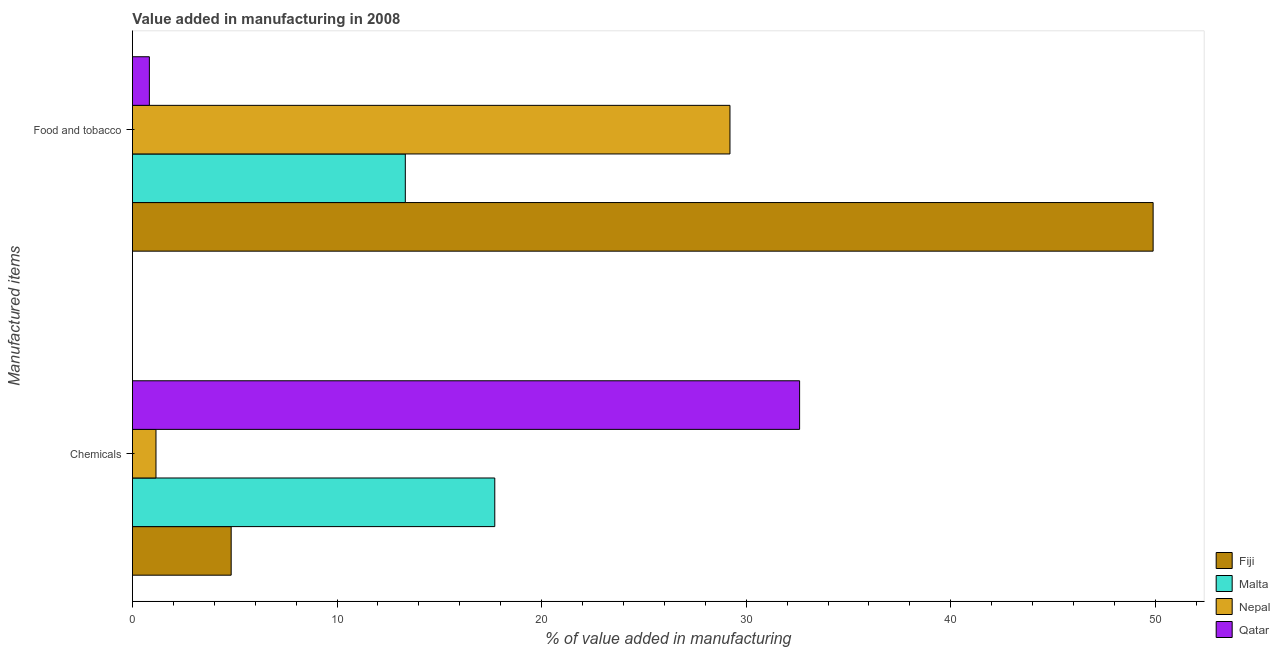How many groups of bars are there?
Provide a succinct answer. 2. How many bars are there on the 1st tick from the top?
Make the answer very short. 4. What is the label of the 1st group of bars from the top?
Ensure brevity in your answer.  Food and tobacco. What is the value added by  manufacturing chemicals in Fiji?
Keep it short and to the point. 4.83. Across all countries, what is the maximum value added by manufacturing food and tobacco?
Give a very brief answer. 49.89. Across all countries, what is the minimum value added by  manufacturing chemicals?
Give a very brief answer. 1.15. In which country was the value added by  manufacturing chemicals maximum?
Provide a succinct answer. Qatar. In which country was the value added by  manufacturing chemicals minimum?
Offer a terse response. Nepal. What is the total value added by manufacturing food and tobacco in the graph?
Provide a short and direct response. 93.26. What is the difference between the value added by  manufacturing chemicals in Qatar and that in Nepal?
Ensure brevity in your answer.  31.46. What is the difference between the value added by manufacturing food and tobacco in Fiji and the value added by  manufacturing chemicals in Malta?
Your response must be concise. 32.18. What is the average value added by  manufacturing chemicals per country?
Your answer should be very brief. 14.07. What is the difference between the value added by manufacturing food and tobacco and value added by  manufacturing chemicals in Nepal?
Provide a succinct answer. 28.06. In how many countries, is the value added by manufacturing food and tobacco greater than 32 %?
Your answer should be very brief. 1. What is the ratio of the value added by manufacturing food and tobacco in Fiji to that in Malta?
Keep it short and to the point. 3.74. What does the 3rd bar from the top in Chemicals represents?
Your response must be concise. Malta. What does the 2nd bar from the bottom in Food and tobacco represents?
Your answer should be very brief. Malta. How many countries are there in the graph?
Keep it short and to the point. 4. Does the graph contain any zero values?
Your response must be concise. No. How many legend labels are there?
Offer a very short reply. 4. What is the title of the graph?
Offer a terse response. Value added in manufacturing in 2008. Does "Turks and Caicos Islands" appear as one of the legend labels in the graph?
Give a very brief answer. No. What is the label or title of the X-axis?
Offer a terse response. % of value added in manufacturing. What is the label or title of the Y-axis?
Your answer should be very brief. Manufactured items. What is the % of value added in manufacturing of Fiji in Chemicals?
Ensure brevity in your answer.  4.83. What is the % of value added in manufacturing in Malta in Chemicals?
Ensure brevity in your answer.  17.71. What is the % of value added in manufacturing of Nepal in Chemicals?
Offer a very short reply. 1.15. What is the % of value added in manufacturing of Qatar in Chemicals?
Offer a very short reply. 32.61. What is the % of value added in manufacturing of Fiji in Food and tobacco?
Ensure brevity in your answer.  49.89. What is the % of value added in manufacturing of Malta in Food and tobacco?
Your answer should be compact. 13.34. What is the % of value added in manufacturing in Nepal in Food and tobacco?
Keep it short and to the point. 29.21. What is the % of value added in manufacturing of Qatar in Food and tobacco?
Provide a succinct answer. 0.83. Across all Manufactured items, what is the maximum % of value added in manufacturing of Fiji?
Keep it short and to the point. 49.89. Across all Manufactured items, what is the maximum % of value added in manufacturing of Malta?
Your response must be concise. 17.71. Across all Manufactured items, what is the maximum % of value added in manufacturing of Nepal?
Make the answer very short. 29.21. Across all Manufactured items, what is the maximum % of value added in manufacturing of Qatar?
Provide a succinct answer. 32.61. Across all Manufactured items, what is the minimum % of value added in manufacturing in Fiji?
Offer a very short reply. 4.83. Across all Manufactured items, what is the minimum % of value added in manufacturing of Malta?
Give a very brief answer. 13.34. Across all Manufactured items, what is the minimum % of value added in manufacturing of Nepal?
Make the answer very short. 1.15. Across all Manufactured items, what is the minimum % of value added in manufacturing in Qatar?
Give a very brief answer. 0.83. What is the total % of value added in manufacturing of Fiji in the graph?
Offer a very short reply. 54.72. What is the total % of value added in manufacturing of Malta in the graph?
Offer a very short reply. 31.05. What is the total % of value added in manufacturing of Nepal in the graph?
Your answer should be compact. 30.36. What is the total % of value added in manufacturing of Qatar in the graph?
Your response must be concise. 33.44. What is the difference between the % of value added in manufacturing in Fiji in Chemicals and that in Food and tobacco?
Provide a succinct answer. -45.06. What is the difference between the % of value added in manufacturing of Malta in Chemicals and that in Food and tobacco?
Your response must be concise. 4.37. What is the difference between the % of value added in manufacturing in Nepal in Chemicals and that in Food and tobacco?
Your answer should be very brief. -28.06. What is the difference between the % of value added in manufacturing in Qatar in Chemicals and that in Food and tobacco?
Your answer should be compact. 31.78. What is the difference between the % of value added in manufacturing of Fiji in Chemicals and the % of value added in manufacturing of Malta in Food and tobacco?
Give a very brief answer. -8.51. What is the difference between the % of value added in manufacturing in Fiji in Chemicals and the % of value added in manufacturing in Nepal in Food and tobacco?
Your answer should be compact. -24.38. What is the difference between the % of value added in manufacturing of Fiji in Chemicals and the % of value added in manufacturing of Qatar in Food and tobacco?
Keep it short and to the point. 4. What is the difference between the % of value added in manufacturing in Malta in Chemicals and the % of value added in manufacturing in Nepal in Food and tobacco?
Your answer should be compact. -11.5. What is the difference between the % of value added in manufacturing of Malta in Chemicals and the % of value added in manufacturing of Qatar in Food and tobacco?
Your answer should be very brief. 16.88. What is the difference between the % of value added in manufacturing in Nepal in Chemicals and the % of value added in manufacturing in Qatar in Food and tobacco?
Offer a very short reply. 0.32. What is the average % of value added in manufacturing in Fiji per Manufactured items?
Your response must be concise. 27.36. What is the average % of value added in manufacturing in Malta per Manufactured items?
Offer a very short reply. 15.52. What is the average % of value added in manufacturing of Nepal per Manufactured items?
Keep it short and to the point. 15.18. What is the average % of value added in manufacturing in Qatar per Manufactured items?
Offer a terse response. 16.72. What is the difference between the % of value added in manufacturing in Fiji and % of value added in manufacturing in Malta in Chemicals?
Provide a short and direct response. -12.88. What is the difference between the % of value added in manufacturing in Fiji and % of value added in manufacturing in Nepal in Chemicals?
Your answer should be compact. 3.68. What is the difference between the % of value added in manufacturing in Fiji and % of value added in manufacturing in Qatar in Chemicals?
Keep it short and to the point. -27.78. What is the difference between the % of value added in manufacturing of Malta and % of value added in manufacturing of Nepal in Chemicals?
Give a very brief answer. 16.56. What is the difference between the % of value added in manufacturing of Malta and % of value added in manufacturing of Qatar in Chemicals?
Your response must be concise. -14.9. What is the difference between the % of value added in manufacturing in Nepal and % of value added in manufacturing in Qatar in Chemicals?
Ensure brevity in your answer.  -31.46. What is the difference between the % of value added in manufacturing of Fiji and % of value added in manufacturing of Malta in Food and tobacco?
Offer a very short reply. 36.55. What is the difference between the % of value added in manufacturing in Fiji and % of value added in manufacturing in Nepal in Food and tobacco?
Give a very brief answer. 20.68. What is the difference between the % of value added in manufacturing of Fiji and % of value added in manufacturing of Qatar in Food and tobacco?
Offer a terse response. 49.06. What is the difference between the % of value added in manufacturing in Malta and % of value added in manufacturing in Nepal in Food and tobacco?
Offer a terse response. -15.87. What is the difference between the % of value added in manufacturing in Malta and % of value added in manufacturing in Qatar in Food and tobacco?
Offer a terse response. 12.51. What is the difference between the % of value added in manufacturing in Nepal and % of value added in manufacturing in Qatar in Food and tobacco?
Your answer should be compact. 28.38. What is the ratio of the % of value added in manufacturing in Fiji in Chemicals to that in Food and tobacco?
Offer a terse response. 0.1. What is the ratio of the % of value added in manufacturing in Malta in Chemicals to that in Food and tobacco?
Make the answer very short. 1.33. What is the ratio of the % of value added in manufacturing of Nepal in Chemicals to that in Food and tobacco?
Offer a very short reply. 0.04. What is the ratio of the % of value added in manufacturing of Qatar in Chemicals to that in Food and tobacco?
Ensure brevity in your answer.  39.39. What is the difference between the highest and the second highest % of value added in manufacturing of Fiji?
Keep it short and to the point. 45.06. What is the difference between the highest and the second highest % of value added in manufacturing of Malta?
Your response must be concise. 4.37. What is the difference between the highest and the second highest % of value added in manufacturing of Nepal?
Your response must be concise. 28.06. What is the difference between the highest and the second highest % of value added in manufacturing of Qatar?
Offer a very short reply. 31.78. What is the difference between the highest and the lowest % of value added in manufacturing in Fiji?
Provide a succinct answer. 45.06. What is the difference between the highest and the lowest % of value added in manufacturing of Malta?
Keep it short and to the point. 4.37. What is the difference between the highest and the lowest % of value added in manufacturing in Nepal?
Provide a succinct answer. 28.06. What is the difference between the highest and the lowest % of value added in manufacturing of Qatar?
Ensure brevity in your answer.  31.78. 